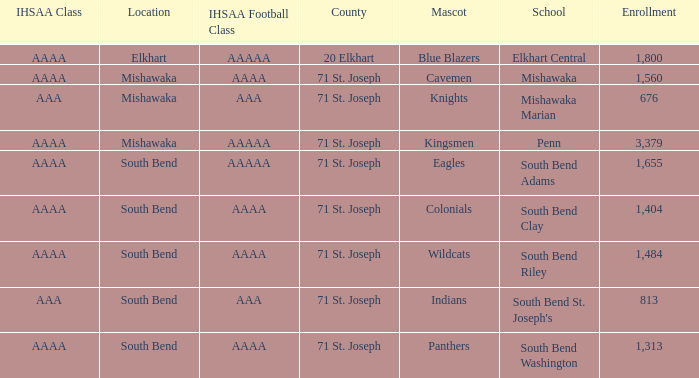Would you be able to parse every entry in this table? {'header': ['IHSAA Class', 'Location', 'IHSAA Football Class', 'County', 'Mascot', 'School', 'Enrollment'], 'rows': [['AAAA', 'Elkhart', 'AAAAA', '20 Elkhart', 'Blue Blazers', 'Elkhart Central', '1,800'], ['AAAA', 'Mishawaka', 'AAAA', '71 St. Joseph', 'Cavemen', 'Mishawaka', '1,560'], ['AAA', 'Mishawaka', 'AAA', '71 St. Joseph', 'Knights', 'Mishawaka Marian', '676'], ['AAAA', 'Mishawaka', 'AAAAA', '71 St. Joseph', 'Kingsmen', 'Penn', '3,379'], ['AAAA', 'South Bend', 'AAAAA', '71 St. Joseph', 'Eagles', 'South Bend Adams', '1,655'], ['AAAA', 'South Bend', 'AAAA', '71 St. Joseph', 'Colonials', 'South Bend Clay', '1,404'], ['AAAA', 'South Bend', 'AAAA', '71 St. Joseph', 'Wildcats', 'South Bend Riley', '1,484'], ['AAA', 'South Bend', 'AAA', '71 St. Joseph', 'Indians', "South Bend St. Joseph's", '813'], ['AAAA', 'South Bend', 'AAAA', '71 St. Joseph', 'Panthers', 'South Bend Washington', '1,313']]} What IHSAA Football Class has 20 elkhart as the county? AAAAA. 